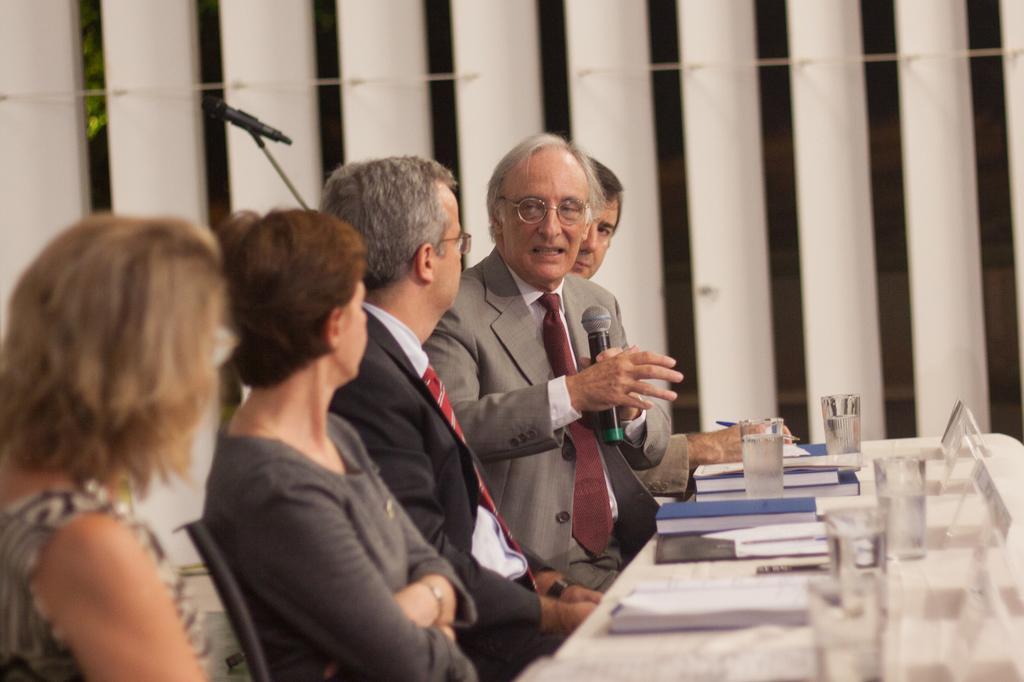Can you describe this image briefly? There are some people sitting on chairs. A person wearing specs is holding a mic. In front of them there is a table. On that there are books, glasses and some other items. In the back there are pillars and mic with mic stand. 